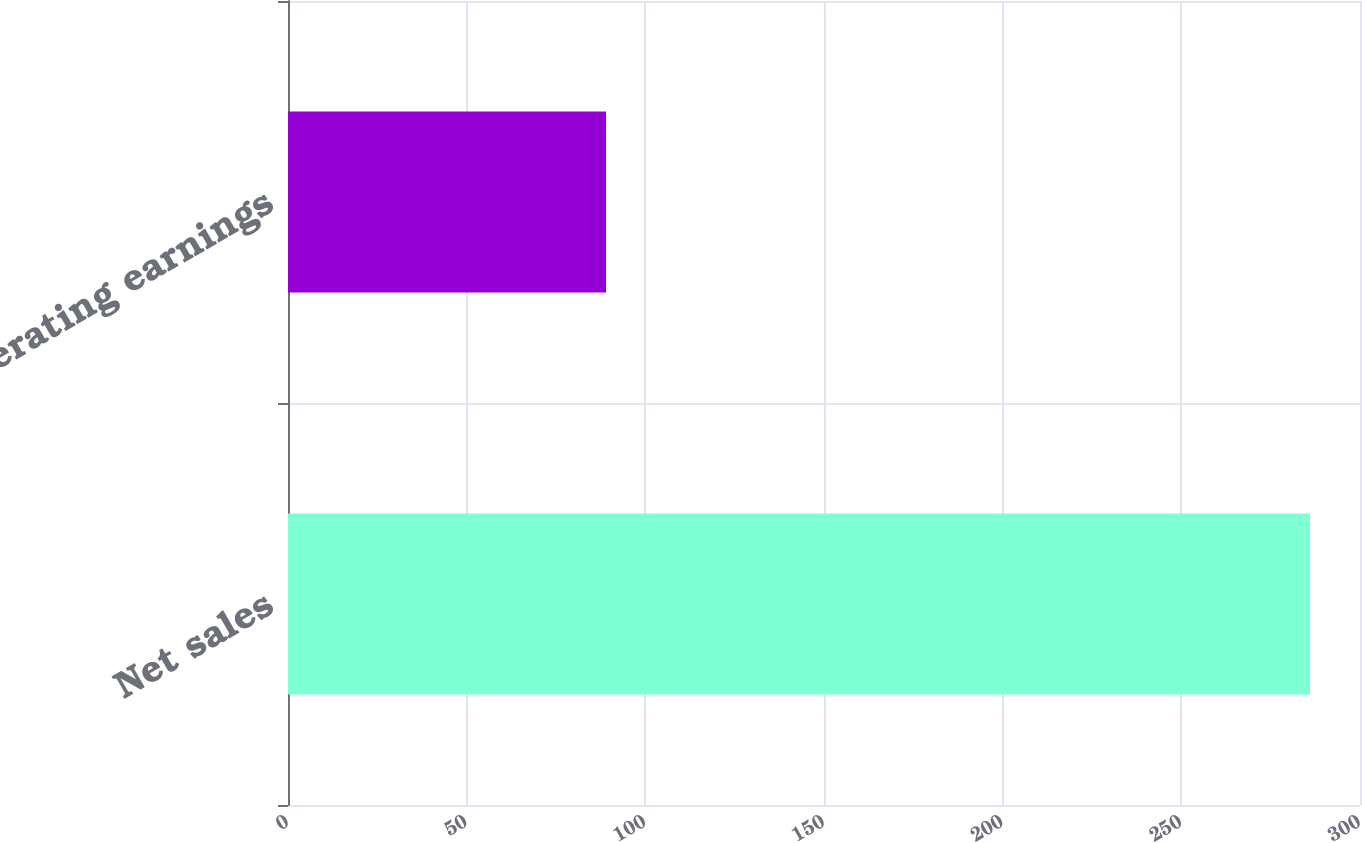Convert chart. <chart><loc_0><loc_0><loc_500><loc_500><bar_chart><fcel>Net sales<fcel>Operating earnings<nl><fcel>286<fcel>89<nl></chart> 